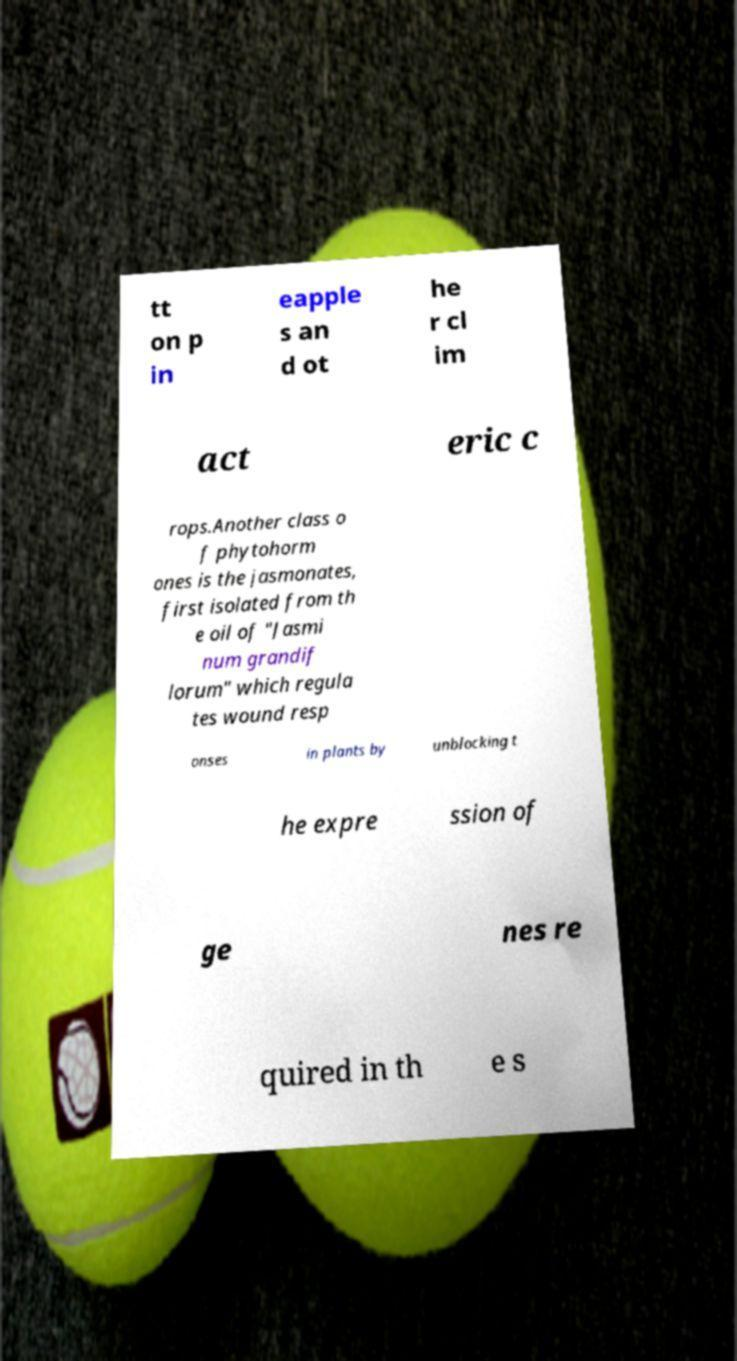Could you extract and type out the text from this image? tt on p in eapple s an d ot he r cl im act eric c rops.Another class o f phytohorm ones is the jasmonates, first isolated from th e oil of "Jasmi num grandif lorum" which regula tes wound resp onses in plants by unblocking t he expre ssion of ge nes re quired in th e s 